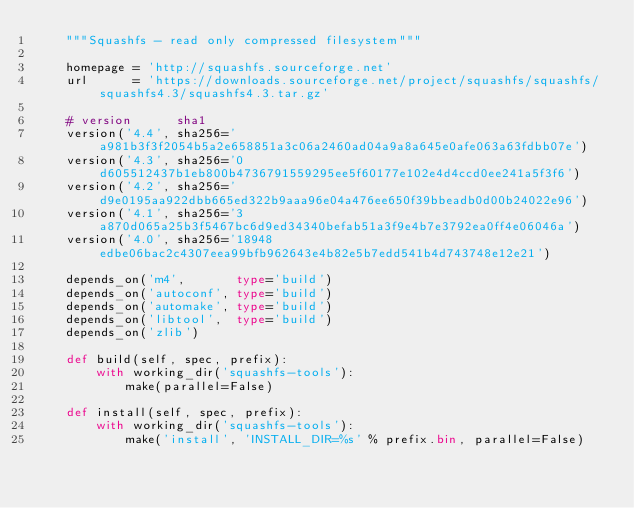<code> <loc_0><loc_0><loc_500><loc_500><_Python_>    """Squashfs - read only compressed filesystem"""

    homepage = 'http://squashfs.sourceforge.net'
    url      = 'https://downloads.sourceforge.net/project/squashfs/squashfs/squashfs4.3/squashfs4.3.tar.gz'

    # version      sha1
    version('4.4', sha256='a981b3f3f2054b5a2e658851a3c06a2460ad04a9a8a645e0afe063a63fdbb07e')
    version('4.3', sha256='0d605512437b1eb800b4736791559295ee5f60177e102e4d4ccd0ee241a5f3f6')
    version('4.2', sha256='d9e0195aa922dbb665ed322b9aaa96e04a476ee650f39bbeadb0d00b24022e96')
    version('4.1', sha256='3a870d065a25b3f5467bc6d9ed34340befab51a3f9e4b7e3792ea0ff4e06046a')
    version('4.0', sha256='18948edbe06bac2c4307eea99bfb962643e4b82e5b7edd541b4d743748e12e21')

    depends_on('m4',       type='build')
    depends_on('autoconf', type='build')
    depends_on('automake', type='build')
    depends_on('libtool',  type='build')
    depends_on('zlib')

    def build(self, spec, prefix):
        with working_dir('squashfs-tools'):
            make(parallel=False)

    def install(self, spec, prefix):
        with working_dir('squashfs-tools'):
            make('install', 'INSTALL_DIR=%s' % prefix.bin, parallel=False)
</code> 